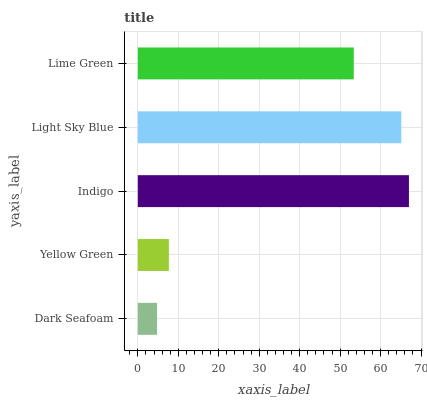Is Dark Seafoam the minimum?
Answer yes or no. Yes. Is Indigo the maximum?
Answer yes or no. Yes. Is Yellow Green the minimum?
Answer yes or no. No. Is Yellow Green the maximum?
Answer yes or no. No. Is Yellow Green greater than Dark Seafoam?
Answer yes or no. Yes. Is Dark Seafoam less than Yellow Green?
Answer yes or no. Yes. Is Dark Seafoam greater than Yellow Green?
Answer yes or no. No. Is Yellow Green less than Dark Seafoam?
Answer yes or no. No. Is Lime Green the high median?
Answer yes or no. Yes. Is Lime Green the low median?
Answer yes or no. Yes. Is Indigo the high median?
Answer yes or no. No. Is Yellow Green the low median?
Answer yes or no. No. 